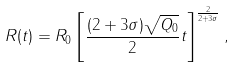<formula> <loc_0><loc_0><loc_500><loc_500>R ( t ) = R _ { 0 } \left [ \frac { ( 2 + 3 \sigma ) \sqrt { Q _ { 0 } } } { 2 } t \right ] ^ { \frac { 2 } { 2 + 3 \sigma } } ,</formula> 